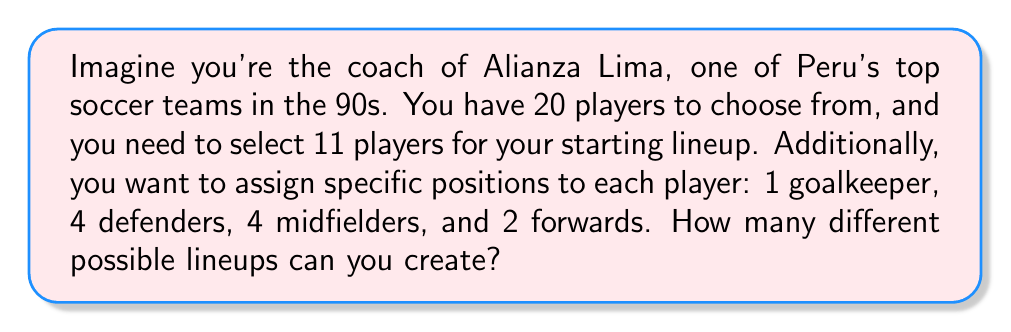Can you answer this question? Let's break this down step-by-step:

1) First, we need to choose 1 goalkeeper out of the 20 players:
   $${20 \choose 1} = 20$$

2) After selecting the goalkeeper, we have 19 players left. From these, we need to choose 4 defenders:
   $${19 \choose 4} = 3876$$

3) After selecting the defenders, we have 15 players left. From these, we need to choose 4 midfielders:
   $${15 \choose 4} = 1365$$

4) Finally, from the remaining 11 players, we need to choose 2 forwards:
   $${11 \choose 2} = 55$$

5) According to the multiplication principle, the total number of ways to make these selections is the product of the individual selections:

   $$20 \times 3876 \times 1365 \times 55$$

6) Calculating this:
   $$20 \times 3876 \times 1365 \times 55 = 5,812,620,000$$

Therefore, there are 5,812,620,000 different possible lineups.
Answer: $$5,812,620,000$$ 